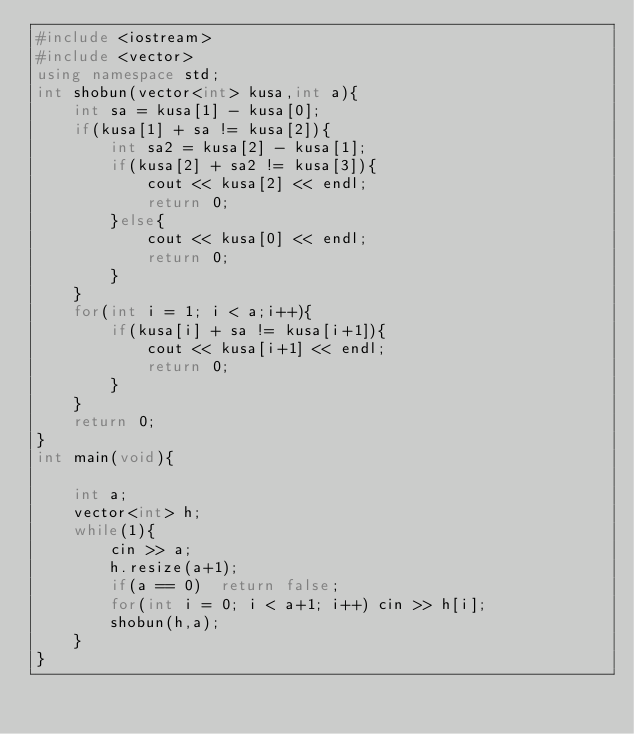<code> <loc_0><loc_0><loc_500><loc_500><_C++_>#include <iostream>
#include <vector>
using namespace std;
int shobun(vector<int> kusa,int a){
    int sa = kusa[1] - kusa[0];
    if(kusa[1] + sa != kusa[2]){
        int sa2 = kusa[2] - kusa[1];
        if(kusa[2] + sa2 != kusa[3]){
            cout << kusa[2] << endl;
            return 0;
        }else{
            cout << kusa[0] << endl;
            return 0;
        }
    }
    for(int i = 1; i < a;i++){
        if(kusa[i] + sa != kusa[i+1]){
            cout << kusa[i+1] << endl;
            return 0;
        }
    }
    return 0;
}
int main(void){
    
    int a;
    vector<int> h;
    while(1){
        cin >> a;
        h.resize(a+1);
        if(a == 0)  return false;
        for(int i = 0; i < a+1; i++) cin >> h[i];
        shobun(h,a);
    }
}</code> 